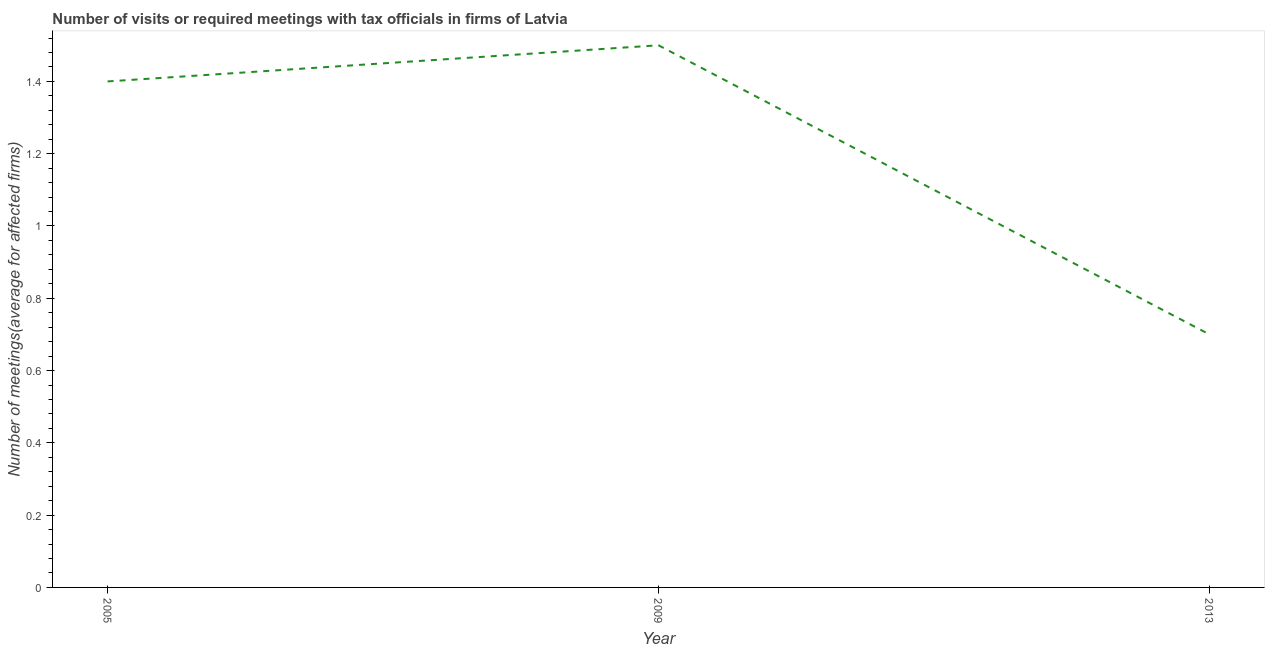What is the number of required meetings with tax officials in 2013?
Provide a short and direct response. 0.7. Across all years, what is the maximum number of required meetings with tax officials?
Provide a short and direct response. 1.5. In which year was the number of required meetings with tax officials maximum?
Provide a short and direct response. 2009. In which year was the number of required meetings with tax officials minimum?
Give a very brief answer. 2013. What is the sum of the number of required meetings with tax officials?
Make the answer very short. 3.6. What is the difference between the number of required meetings with tax officials in 2009 and 2013?
Your answer should be very brief. 0.8. In how many years, is the number of required meetings with tax officials greater than 0.8 ?
Offer a very short reply. 2. Do a majority of the years between 2013 and 2005 (inclusive) have number of required meetings with tax officials greater than 1.3200000000000003 ?
Provide a succinct answer. No. What is the ratio of the number of required meetings with tax officials in 2009 to that in 2013?
Your response must be concise. 2.14. Is the number of required meetings with tax officials in 2009 less than that in 2013?
Give a very brief answer. No. What is the difference between the highest and the second highest number of required meetings with tax officials?
Give a very brief answer. 0.1. Is the sum of the number of required meetings with tax officials in 2005 and 2013 greater than the maximum number of required meetings with tax officials across all years?
Your answer should be compact. Yes. What is the difference between two consecutive major ticks on the Y-axis?
Provide a succinct answer. 0.2. Are the values on the major ticks of Y-axis written in scientific E-notation?
Your response must be concise. No. Does the graph contain grids?
Your answer should be very brief. No. What is the title of the graph?
Provide a short and direct response. Number of visits or required meetings with tax officials in firms of Latvia. What is the label or title of the Y-axis?
Your answer should be compact. Number of meetings(average for affected firms). What is the Number of meetings(average for affected firms) in 2005?
Offer a terse response. 1.4. What is the Number of meetings(average for affected firms) of 2009?
Ensure brevity in your answer.  1.5. What is the Number of meetings(average for affected firms) in 2013?
Your answer should be very brief. 0.7. What is the difference between the Number of meetings(average for affected firms) in 2005 and 2009?
Your answer should be very brief. -0.1. What is the difference between the Number of meetings(average for affected firms) in 2005 and 2013?
Make the answer very short. 0.7. What is the ratio of the Number of meetings(average for affected firms) in 2005 to that in 2009?
Keep it short and to the point. 0.93. What is the ratio of the Number of meetings(average for affected firms) in 2005 to that in 2013?
Your answer should be very brief. 2. What is the ratio of the Number of meetings(average for affected firms) in 2009 to that in 2013?
Offer a very short reply. 2.14. 